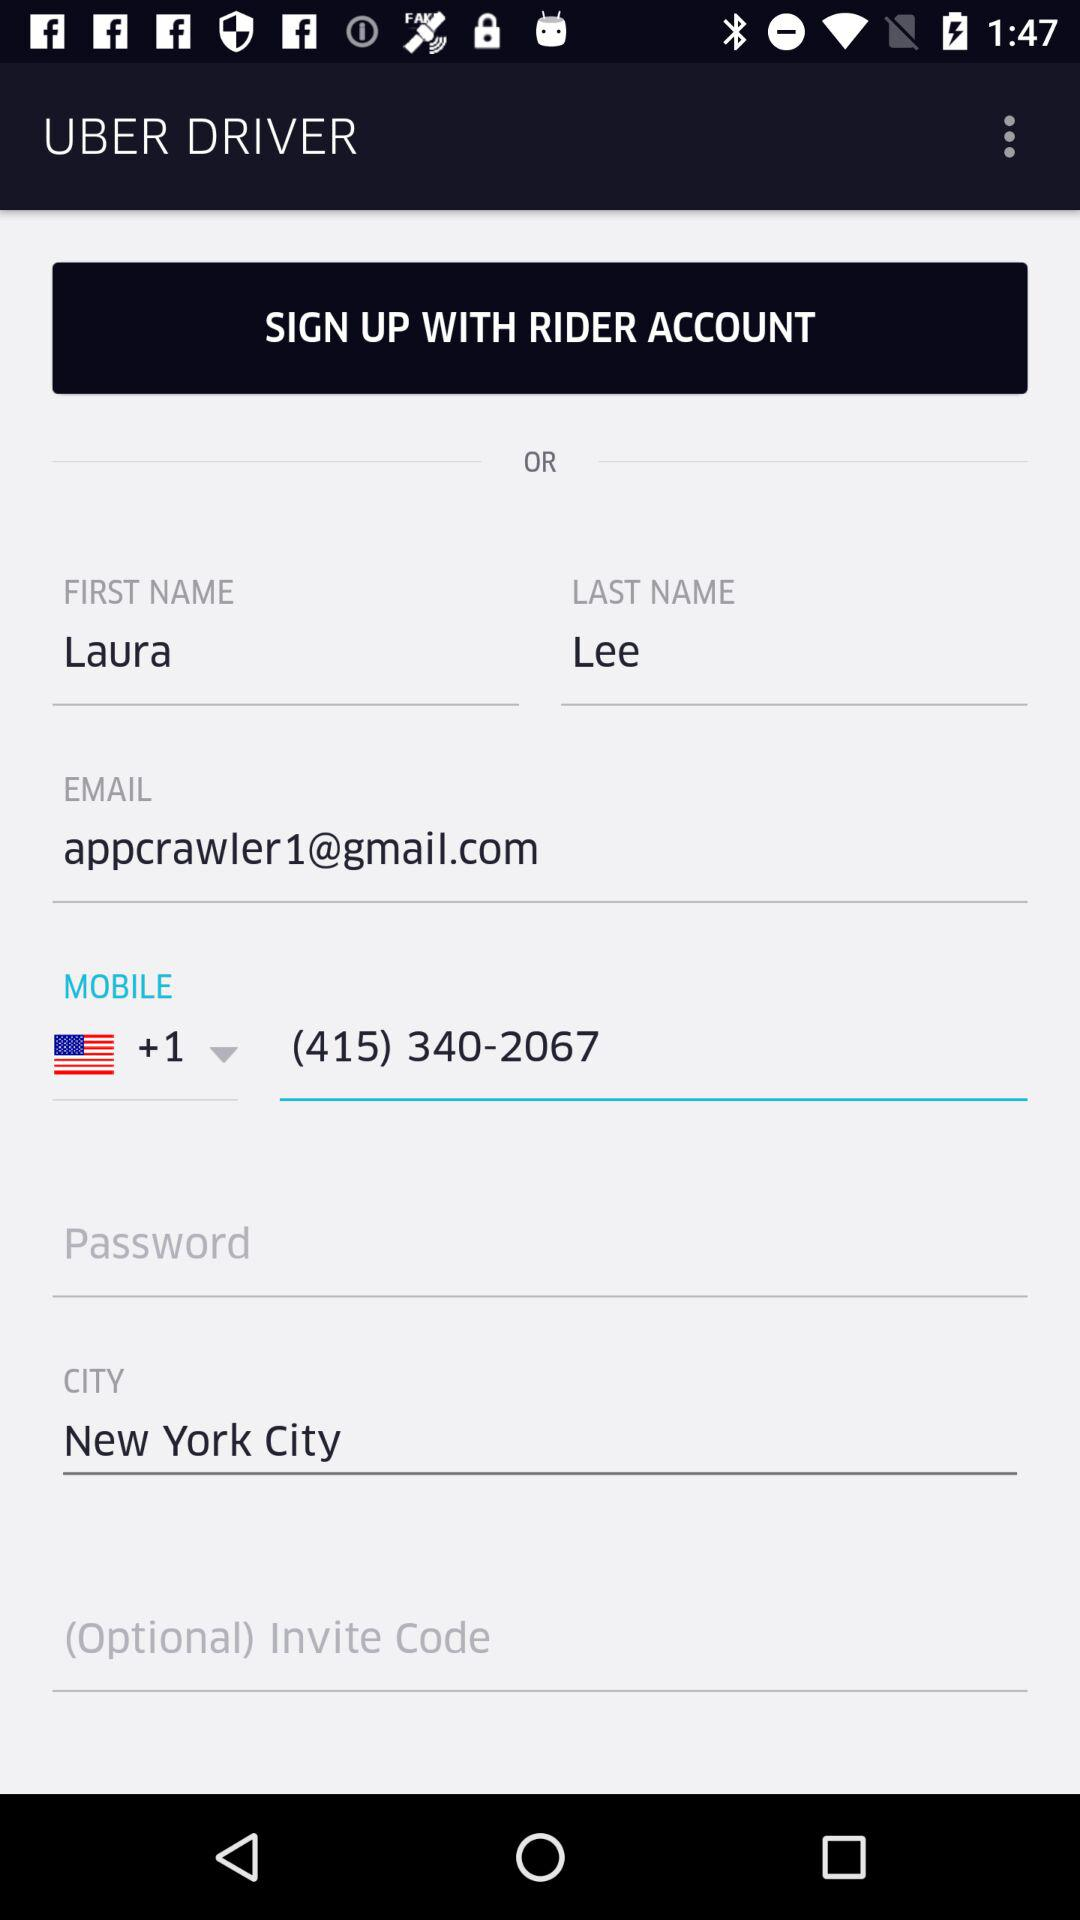What is the email address? The email address is appcrawler1@gmail.com. 